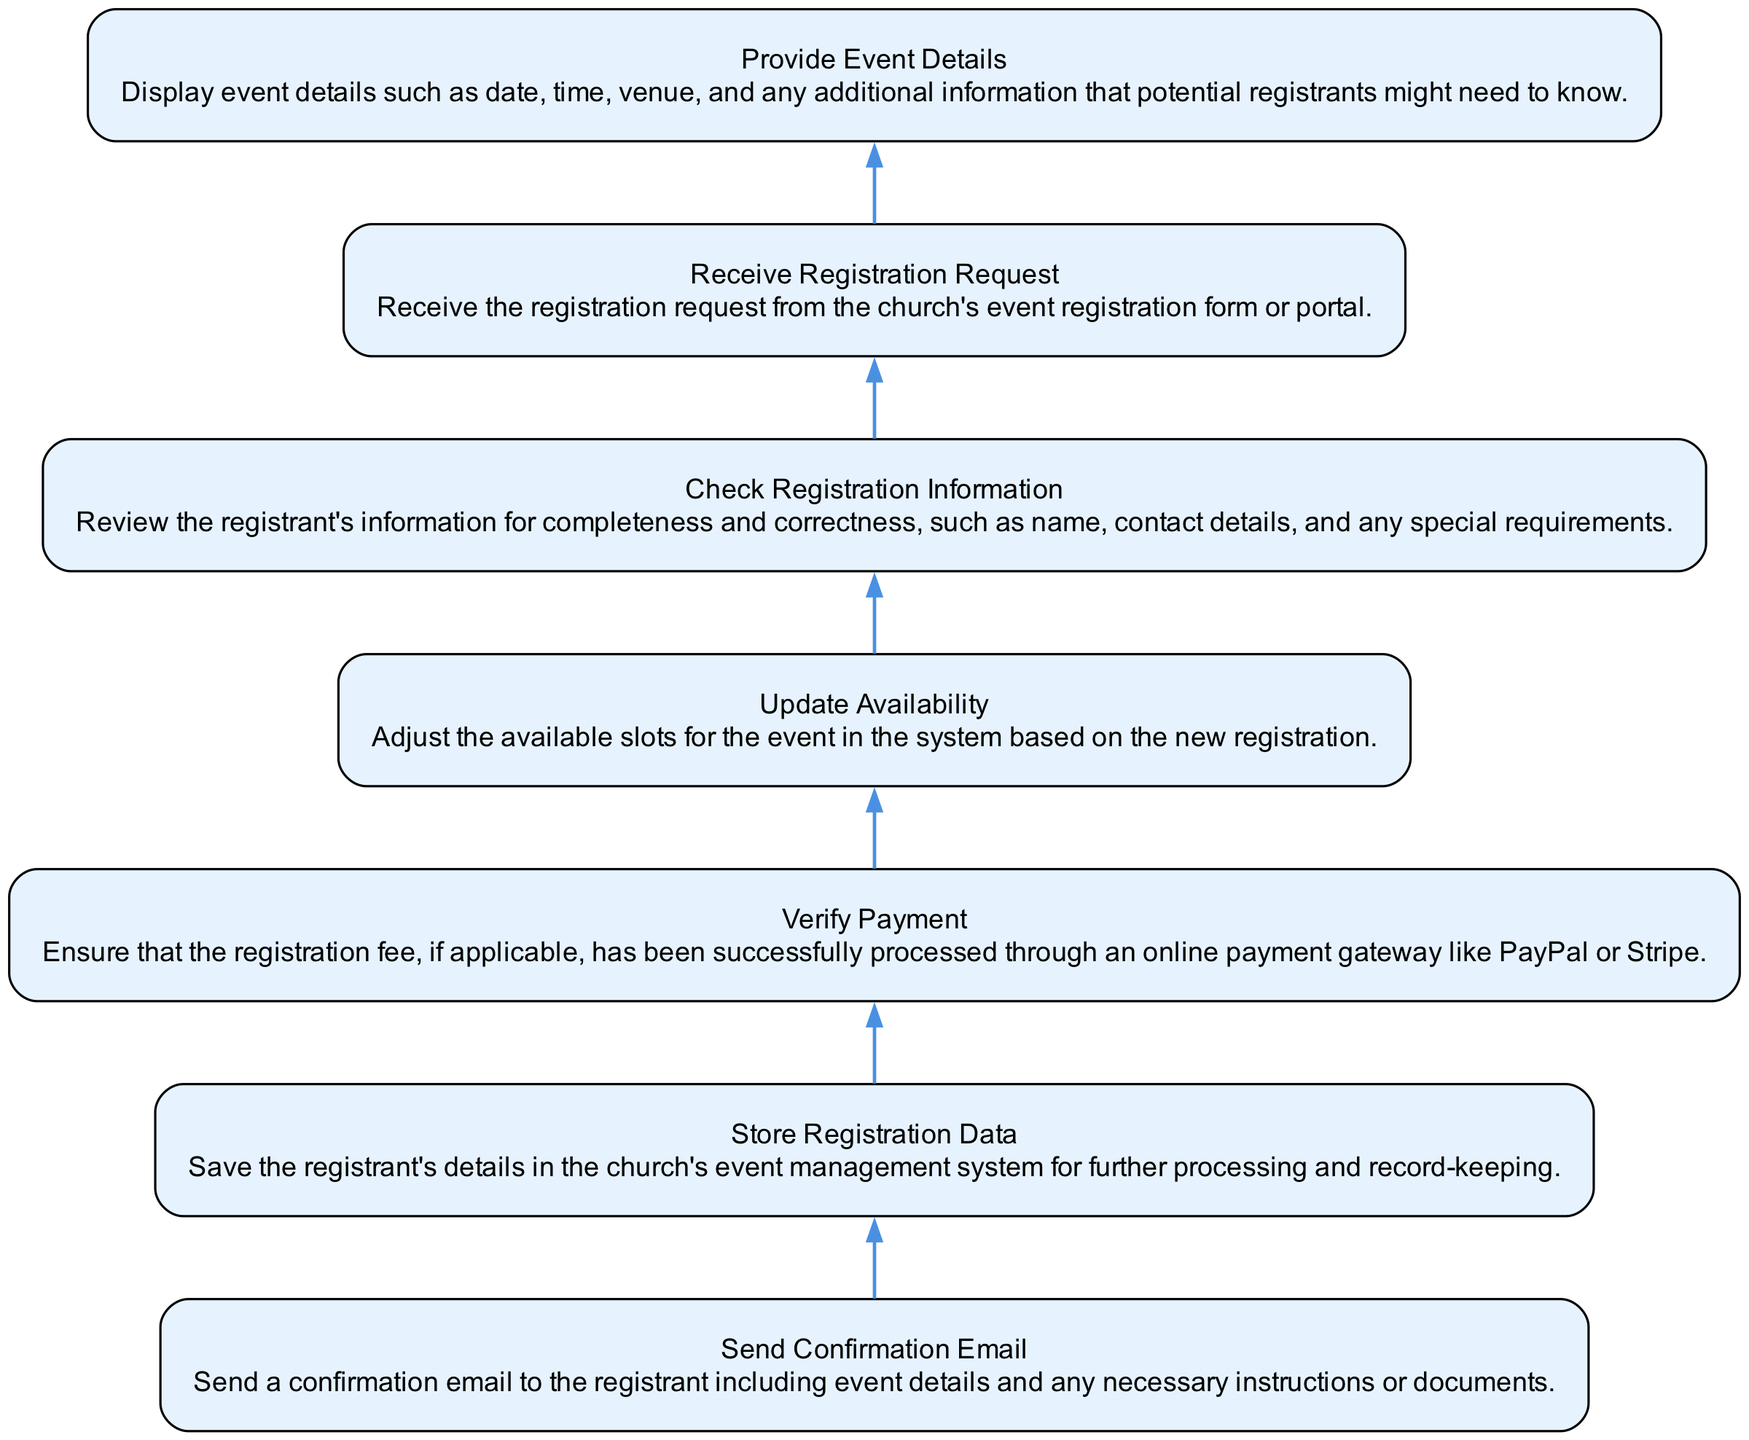What is the first stage in the diagram? The first stage at the bottom of the diagram is "Receive Registration Request". This can be seen as it's the first action that initiates the registration process.
Answer: Receive Registration Request How many stages are there in total? Counting all the stages listed in the diagram, there are seven distinct stages that make up the flow of managing event registrations.
Answer: Seven What is the immediate next stage after "Verify Payment"? The stage that follows "Verify Payment" is "Update Availability". This is determined by following the flow of the diagram from one stage to the next.
Answer: Update Availability Which stage involves sending a confirmation? The stage where a confirmation email is sent is "Send Confirmation Email". This action specifically indicates the communication step after the registration process has been verified.
Answer: Send Confirmation Email What stage occurs before data is stored? The stage that takes place before storing data is "Check Registration Information". This is confirmed by looking at the order of the stages in the flowchart.
Answer: Check Registration Information What action is taken after "Update Availability"? Following "Update Availability", the next step in the process is "Send Confirmation Email". This means that the system communicates with the registrant once the availability has been updated.
Answer: Send Confirmation Email What is the primary purpose of the "Store Registration Data" stage? The purpose of this stage is to save registrant details for further processing and record-keeping, as indicated in the description associated with that particular stage.
Answer: Save registrant details Which stage provides potential registrants with event details? The stage that provides event details is "Provide Event Details". This step occurs early on in the process to inform those considering registration.
Answer: Provide Event Details What happens after the eventual confirmation email is sent? In terms of flow, the confirmation email marks the final action in the registration process, indicating that no additional stages follow this. The process concludes at this step.
Answer: Process concludes 